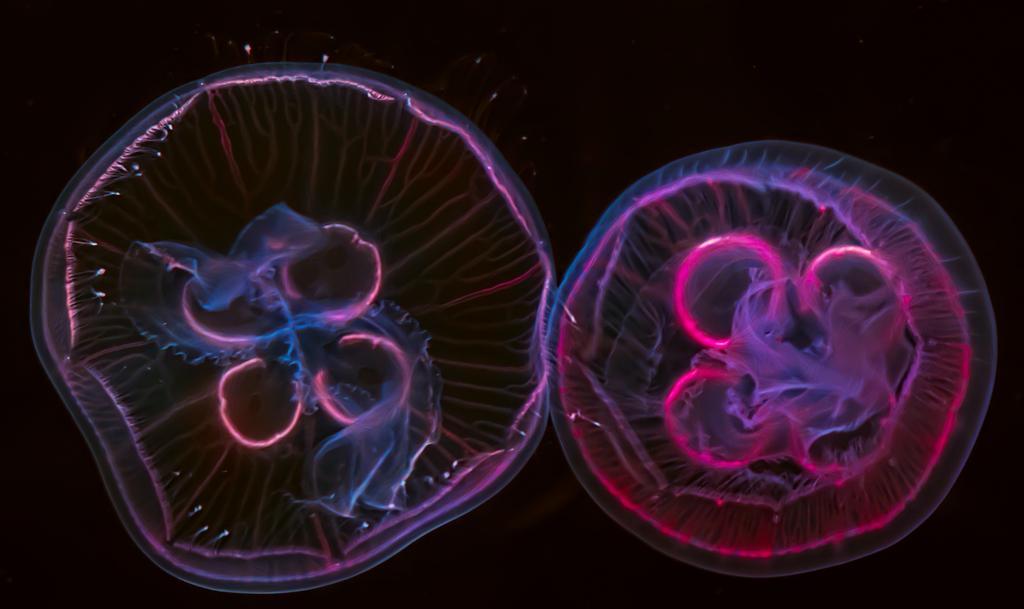Describe this image in one or two sentences. In this image, I can see two jellyfish. The background looks dark. 